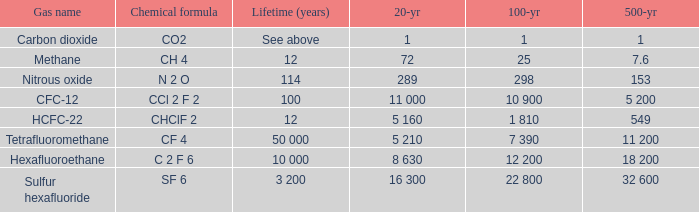Help me parse the entirety of this table. {'header': ['Gas name', 'Chemical formula', 'Lifetime (years)', '20-yr', '100-yr', '500-yr'], 'rows': [['Carbon dioxide', 'CO2', 'See above', '1', '1', '1'], ['Methane', 'CH 4', '12', '72', '25', '7.6'], ['Nitrous oxide', 'N 2 O', '114', '289', '298', '153'], ['CFC-12', 'CCl 2 F 2', '100', '11 000', '10 900', '5 200'], ['HCFC-22', 'CHClF 2', '12', '5 160', '1 810', '549'], ['Tetrafluoromethane', 'CF 4', '50 000', '5 210', '7 390', '11 200'], ['Hexafluoroethane', 'C 2 F 6', '10 000', '8 630', '12 200', '18 200'], ['Sulfur hexafluoride', 'SF 6', '3 200', '16 300', '22 800', '32 600']]} What is the 20 year for Sulfur Hexafluoride? 16 300. 